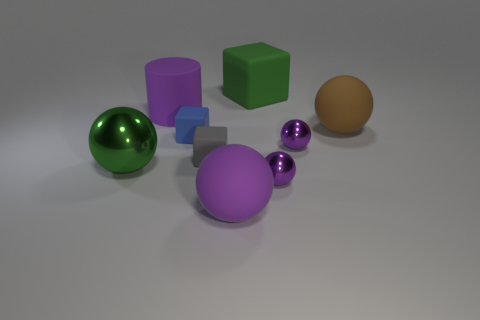Subtract all purple blocks. How many purple spheres are left? 3 Subtract 1 spheres. How many spheres are left? 4 Subtract all brown balls. How many balls are left? 4 Subtract all green spheres. How many spheres are left? 4 Subtract all red balls. Subtract all blue blocks. How many balls are left? 5 Add 1 tiny gray blocks. How many objects exist? 10 Subtract all spheres. How many objects are left? 4 Add 9 purple cylinders. How many purple cylinders are left? 10 Add 4 big red matte blocks. How many big red matte blocks exist? 4 Subtract 0 brown cylinders. How many objects are left? 9 